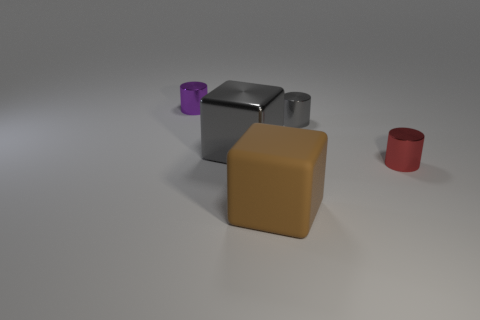How many small objects are either red shiny things or brown things?
Your answer should be compact. 1. Are the red cylinder and the tiny gray object made of the same material?
Offer a terse response. Yes. How many small cylinders are in front of the cube to the left of the brown rubber block?
Your answer should be very brief. 1. Is there a cyan metal thing that has the same shape as the large rubber thing?
Keep it short and to the point. No. There is a small gray object that is behind the shiny block; is its shape the same as the tiny metal object to the left of the big brown rubber thing?
Keep it short and to the point. Yes. What is the shape of the metal object that is both to the left of the tiny red metal thing and in front of the gray cylinder?
Make the answer very short. Cube. Is there a purple shiny cylinder that has the same size as the gray cube?
Your answer should be very brief. No. Does the large metallic block have the same color as the small metallic cylinder in front of the large gray metal block?
Keep it short and to the point. No. What is the small purple object made of?
Make the answer very short. Metal. There is a shiny cylinder left of the big gray block; what is its color?
Offer a very short reply. Purple. 